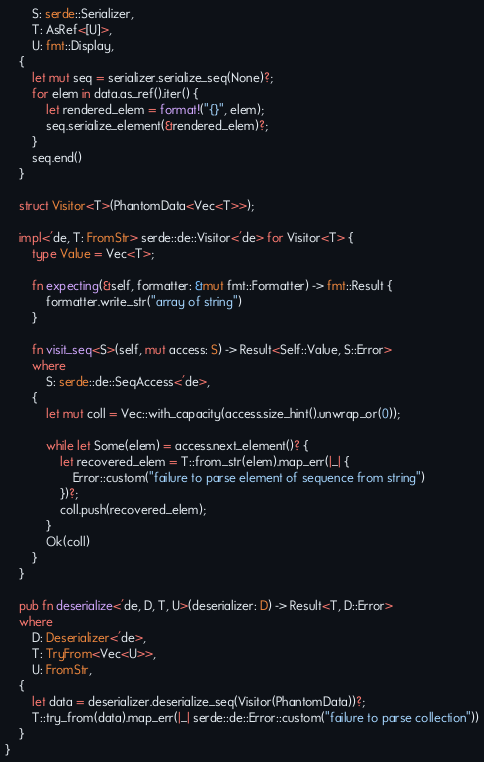<code> <loc_0><loc_0><loc_500><loc_500><_Rust_>        S: serde::Serializer,
        T: AsRef<[U]>,
        U: fmt::Display,
    {
        let mut seq = serializer.serialize_seq(None)?;
        for elem in data.as_ref().iter() {
            let rendered_elem = format!("{}", elem);
            seq.serialize_element(&rendered_elem)?;
        }
        seq.end()
    }

    struct Visitor<T>(PhantomData<Vec<T>>);

    impl<'de, T: FromStr> serde::de::Visitor<'de> for Visitor<T> {
        type Value = Vec<T>;

        fn expecting(&self, formatter: &mut fmt::Formatter) -> fmt::Result {
            formatter.write_str("array of string")
        }

        fn visit_seq<S>(self, mut access: S) -> Result<Self::Value, S::Error>
        where
            S: serde::de::SeqAccess<'de>,
        {
            let mut coll = Vec::with_capacity(access.size_hint().unwrap_or(0));

            while let Some(elem) = access.next_element()? {
                let recovered_elem = T::from_str(elem).map_err(|_| {
                    Error::custom("failure to parse element of sequence from string")
                })?;
                coll.push(recovered_elem);
            }
            Ok(coll)
        }
    }

    pub fn deserialize<'de, D, T, U>(deserializer: D) -> Result<T, D::Error>
    where
        D: Deserializer<'de>,
        T: TryFrom<Vec<U>>,
        U: FromStr,
    {
        let data = deserializer.deserialize_seq(Visitor(PhantomData))?;
        T::try_from(data).map_err(|_| serde::de::Error::custom("failure to parse collection"))
    }
}
</code> 